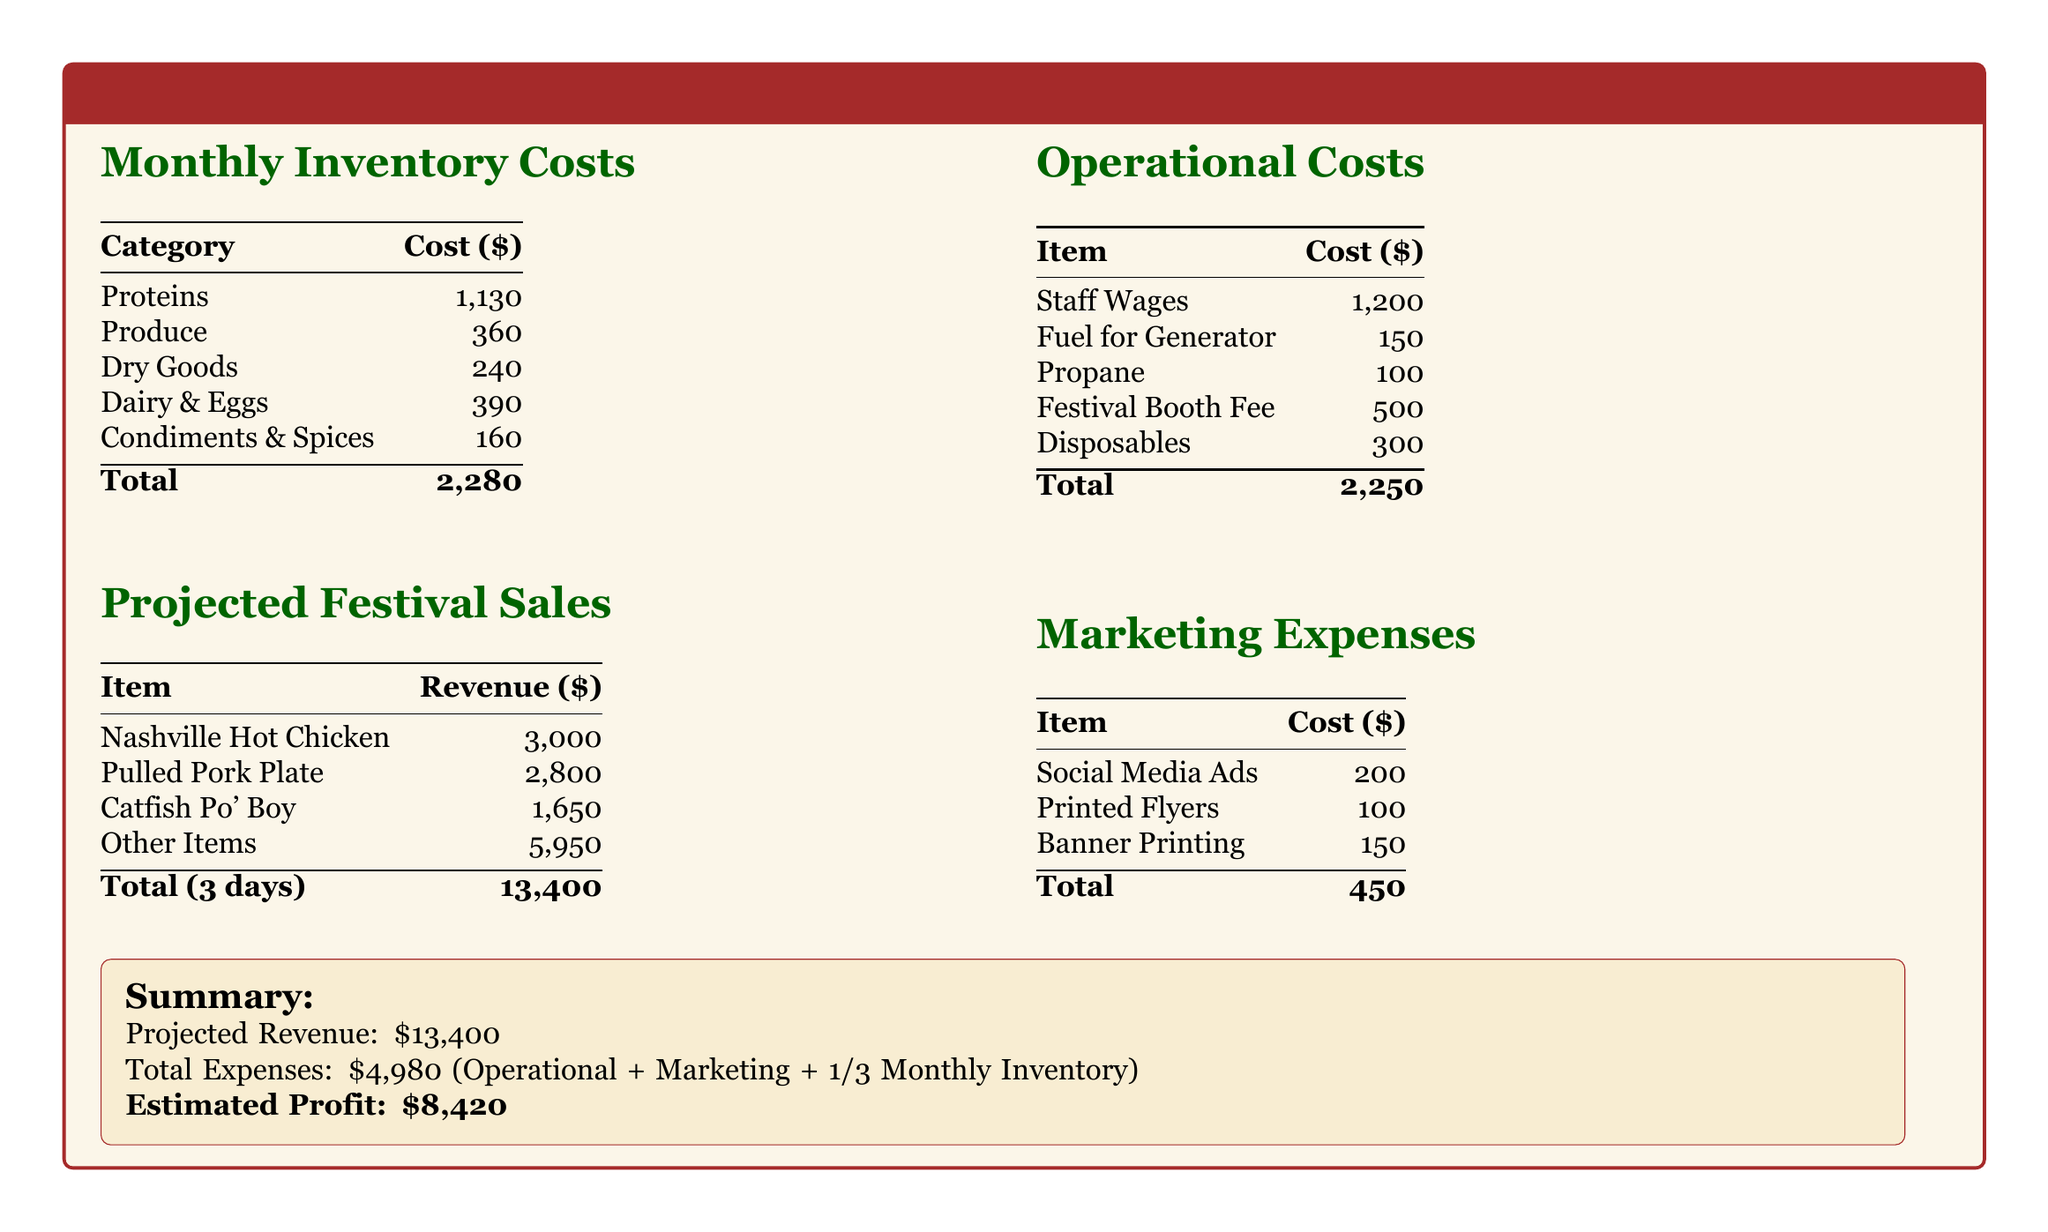What is the total monthly inventory cost? The total monthly inventory cost is listed at the bottom of the inventory costs section in the document.
Answer: 2,280 How much is projected revenue from Nashville Hot Chicken? The revenue from Nashville Hot Chicken is presented in the projected festival sales table.
Answer: 3,000 What is the total operational cost? The total operational cost is found at the bottom of the operational costs section in the document.
Answer: 2,250 What is the cost of condiments and spices? The cost of condiments and spices is specified in the monthly inventory costs table.
Answer: 160 What is the estimated profit? The estimated profit is calculated in the summary section by subtracting total expenses from projected revenue.
Answer: 8,420 How much will be spent on staff wages? The expenditure on staff wages is detailed in the operational costs section of the document.
Answer: 1,200 What percentage of the projected revenue does the total expense represent? The question requires calculating the ratio of total expenses to projected revenue from the summary section.
Answer: Approximately 37.14% What are the marketing expenses in total? The total marketing expenses can be found at the end of the marketing expenses section in the document.
Answer: 450 Which item has the lowest projected revenue? The lowest projected revenue can be identified by comparing the revenue numbers in the projected festival sales table.
Answer: Catfish Po' Boy 